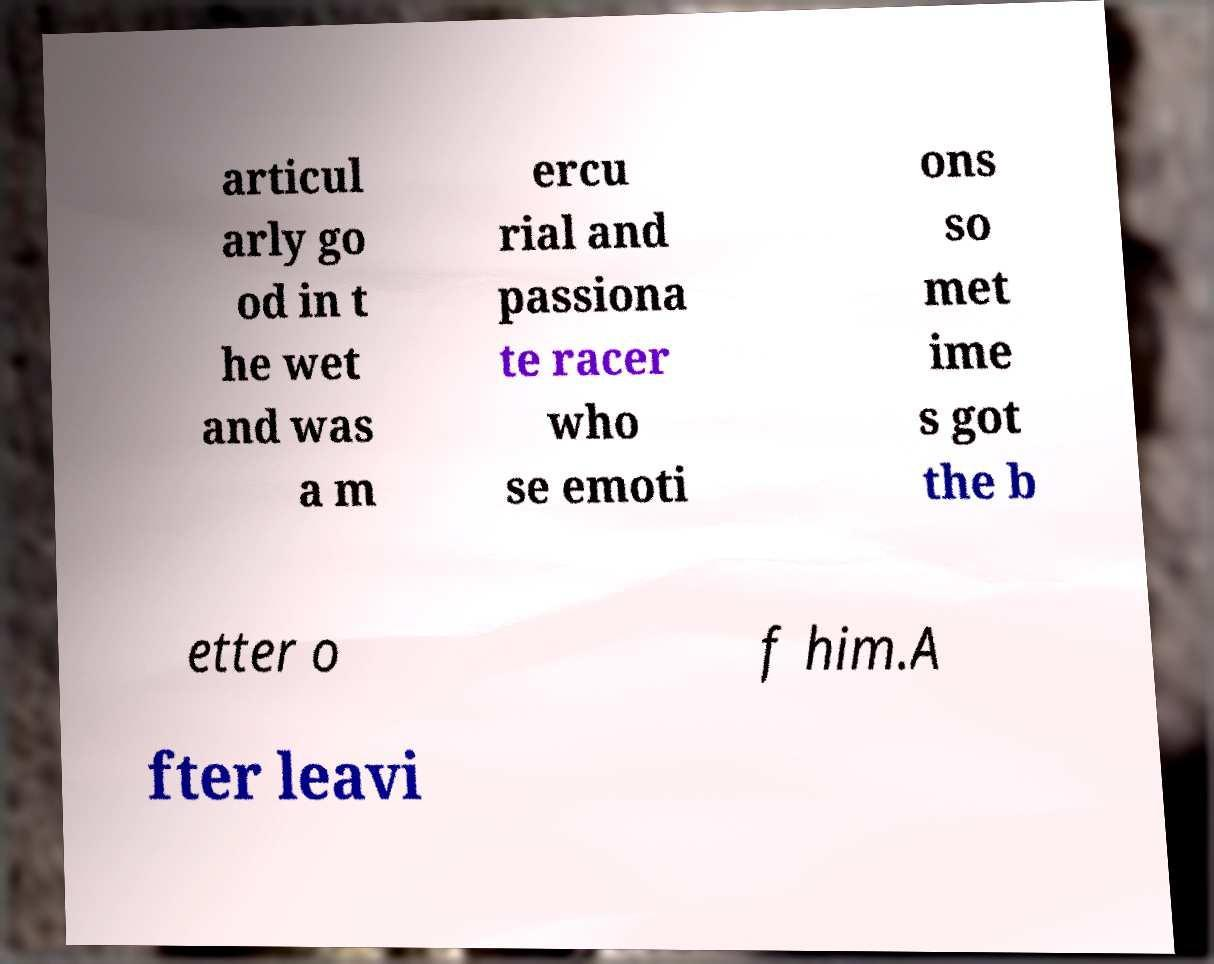I need the written content from this picture converted into text. Can you do that? articul arly go od in t he wet and was a m ercu rial and passiona te racer who se emoti ons so met ime s got the b etter o f him.A fter leavi 